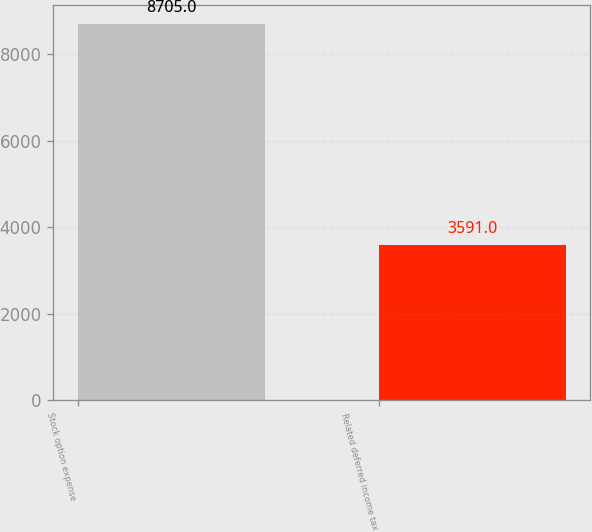Convert chart. <chart><loc_0><loc_0><loc_500><loc_500><bar_chart><fcel>Stock option expense<fcel>Related deferred income tax<nl><fcel>8705<fcel>3591<nl></chart> 